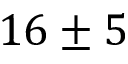Convert formula to latex. <formula><loc_0><loc_0><loc_500><loc_500>1 6 \pm 5</formula> 